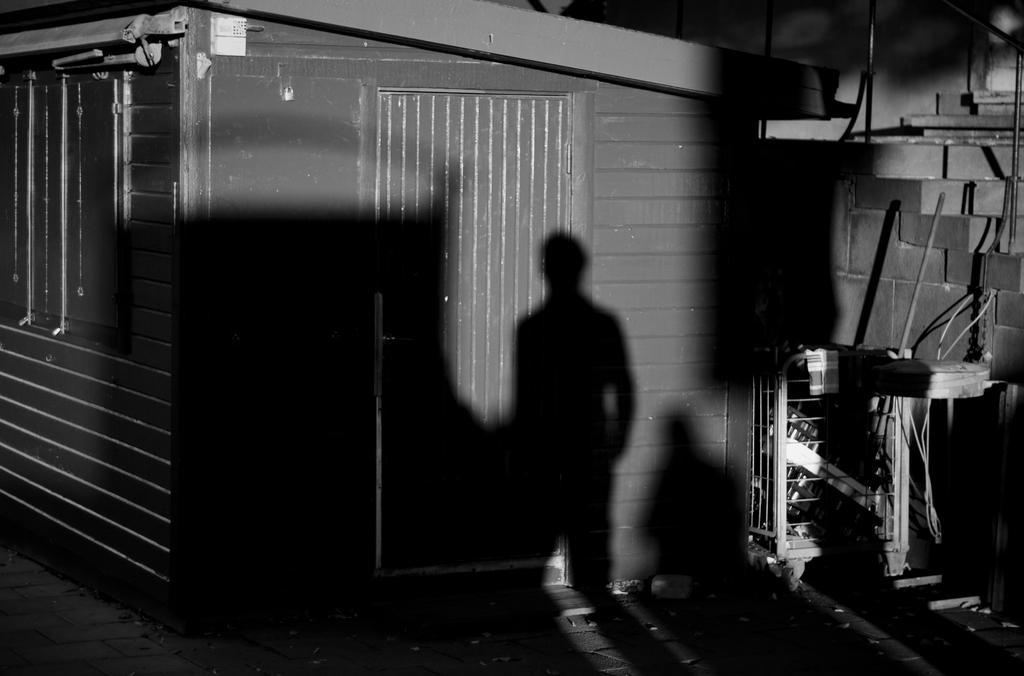How would you summarize this image in a sentence or two? Here we can see shadow of the person and we can see wall and door. 